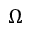<formula> <loc_0><loc_0><loc_500><loc_500>\Omega</formula> 